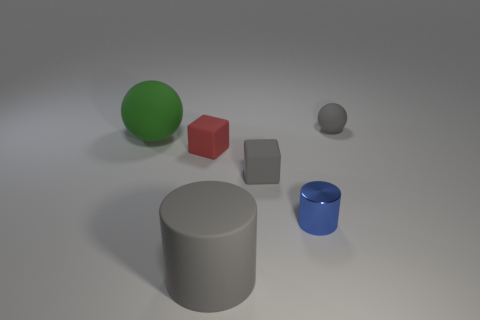Add 3 matte objects. How many objects exist? 9 Subtract all cylinders. How many objects are left? 4 Add 3 gray cubes. How many gray cubes exist? 4 Subtract 0 cyan balls. How many objects are left? 6 Subtract all tiny yellow metallic balls. Subtract all big cylinders. How many objects are left? 5 Add 4 tiny red matte cubes. How many tiny red matte cubes are left? 5 